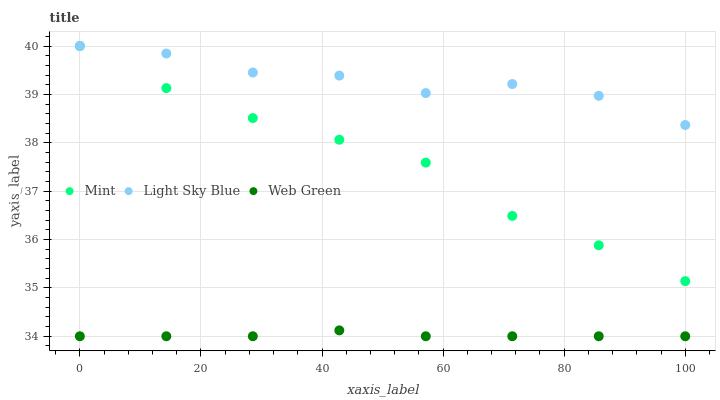Does Web Green have the minimum area under the curve?
Answer yes or no. Yes. Does Light Sky Blue have the maximum area under the curve?
Answer yes or no. Yes. Does Mint have the minimum area under the curve?
Answer yes or no. No. Does Mint have the maximum area under the curve?
Answer yes or no. No. Is Web Green the smoothest?
Answer yes or no. Yes. Is Light Sky Blue the roughest?
Answer yes or no. Yes. Is Mint the smoothest?
Answer yes or no. No. Is Mint the roughest?
Answer yes or no. No. Does Web Green have the lowest value?
Answer yes or no. Yes. Does Mint have the lowest value?
Answer yes or no. No. Does Mint have the highest value?
Answer yes or no. Yes. Does Web Green have the highest value?
Answer yes or no. No. Is Web Green less than Mint?
Answer yes or no. Yes. Is Light Sky Blue greater than Web Green?
Answer yes or no. Yes. Does Mint intersect Light Sky Blue?
Answer yes or no. Yes. Is Mint less than Light Sky Blue?
Answer yes or no. No. Is Mint greater than Light Sky Blue?
Answer yes or no. No. Does Web Green intersect Mint?
Answer yes or no. No. 